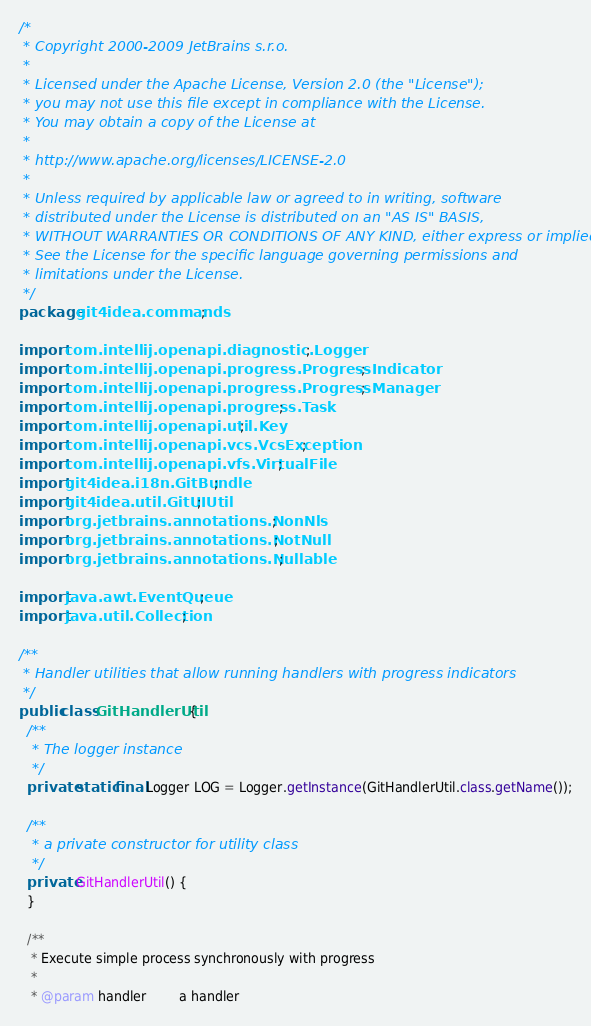<code> <loc_0><loc_0><loc_500><loc_500><_Java_>/*
 * Copyright 2000-2009 JetBrains s.r.o.
 *
 * Licensed under the Apache License, Version 2.0 (the "License");
 * you may not use this file except in compliance with the License.
 * You may obtain a copy of the License at
 *
 * http://www.apache.org/licenses/LICENSE-2.0
 *
 * Unless required by applicable law or agreed to in writing, software
 * distributed under the License is distributed on an "AS IS" BASIS,
 * WITHOUT WARRANTIES OR CONDITIONS OF ANY KIND, either express or implied.
 * See the License for the specific language governing permissions and
 * limitations under the License.
 */
package git4idea.commands;

import com.intellij.openapi.diagnostic.Logger;
import com.intellij.openapi.progress.ProgressIndicator;
import com.intellij.openapi.progress.ProgressManager;
import com.intellij.openapi.progress.Task;
import com.intellij.openapi.util.Key;
import com.intellij.openapi.vcs.VcsException;
import com.intellij.openapi.vfs.VirtualFile;
import git4idea.i18n.GitBundle;
import git4idea.util.GitUIUtil;
import org.jetbrains.annotations.NonNls;
import org.jetbrains.annotations.NotNull;
import org.jetbrains.annotations.Nullable;

import java.awt.EventQueue;
import java.util.Collection;

/**
 * Handler utilities that allow running handlers with progress indicators
 */
public class GitHandlerUtil {
  /**
   * The logger instance
   */
  private static final Logger LOG = Logger.getInstance(GitHandlerUtil.class.getName());

  /**
   * a private constructor for utility class
   */
  private GitHandlerUtil() {
  }

  /**
   * Execute simple process synchronously with progress
   *
   * @param handler        a handler</code> 